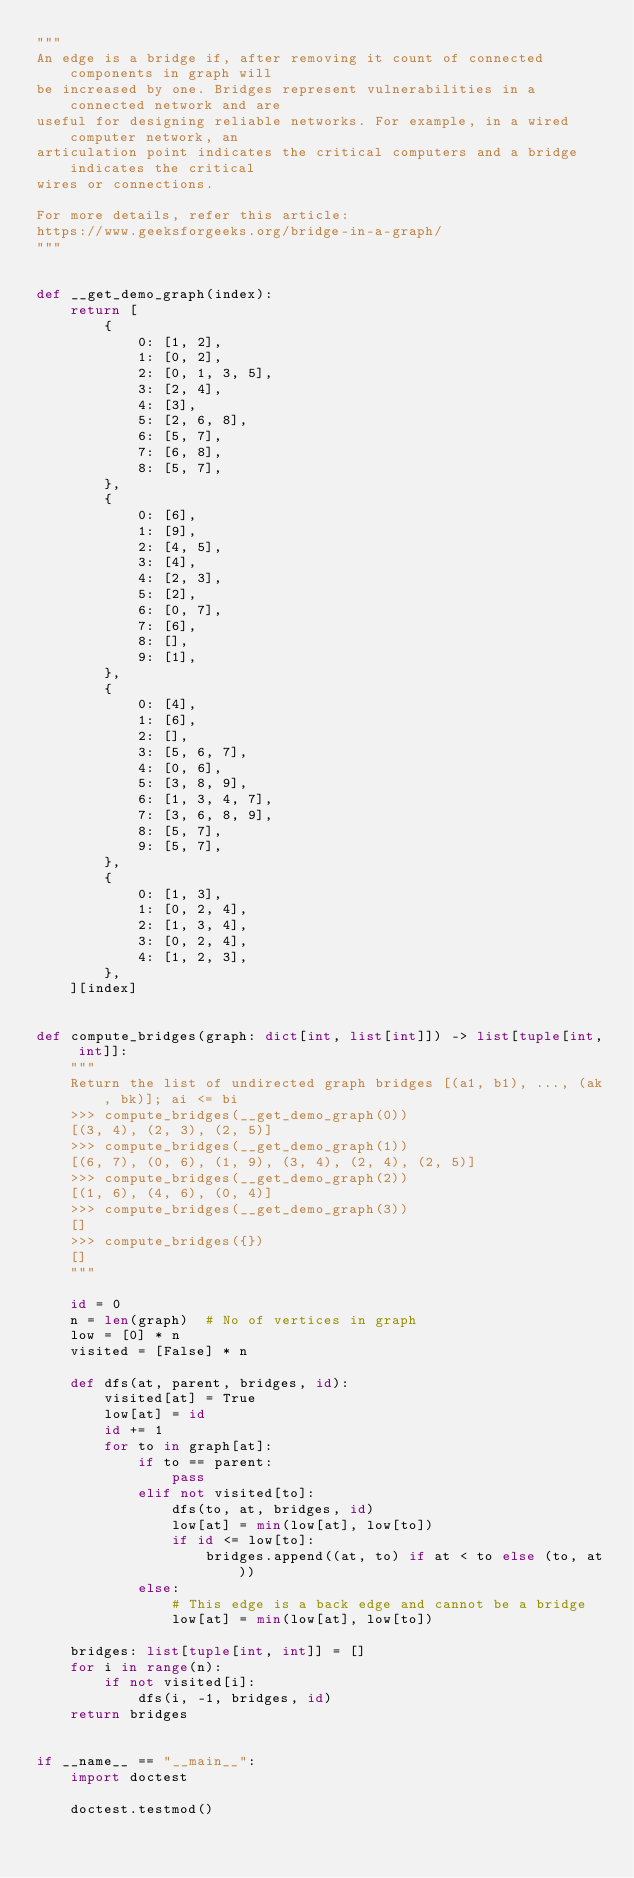<code> <loc_0><loc_0><loc_500><loc_500><_Python_>"""
An edge is a bridge if, after removing it count of connected components in graph will
be increased by one. Bridges represent vulnerabilities in a connected network and are
useful for designing reliable networks. For example, in a wired computer network, an
articulation point indicates the critical computers and a bridge indicates the critical
wires or connections.

For more details, refer this article:
https://www.geeksforgeeks.org/bridge-in-a-graph/
"""


def __get_demo_graph(index):
    return [
        {
            0: [1, 2],
            1: [0, 2],
            2: [0, 1, 3, 5],
            3: [2, 4],
            4: [3],
            5: [2, 6, 8],
            6: [5, 7],
            7: [6, 8],
            8: [5, 7],
        },
        {
            0: [6],
            1: [9],
            2: [4, 5],
            3: [4],
            4: [2, 3],
            5: [2],
            6: [0, 7],
            7: [6],
            8: [],
            9: [1],
        },
        {
            0: [4],
            1: [6],
            2: [],
            3: [5, 6, 7],
            4: [0, 6],
            5: [3, 8, 9],
            6: [1, 3, 4, 7],
            7: [3, 6, 8, 9],
            8: [5, 7],
            9: [5, 7],
        },
        {
            0: [1, 3],
            1: [0, 2, 4],
            2: [1, 3, 4],
            3: [0, 2, 4],
            4: [1, 2, 3],
        },
    ][index]


def compute_bridges(graph: dict[int, list[int]]) -> list[tuple[int, int]]:
    """
    Return the list of undirected graph bridges [(a1, b1), ..., (ak, bk)]; ai <= bi
    >>> compute_bridges(__get_demo_graph(0))
    [(3, 4), (2, 3), (2, 5)]
    >>> compute_bridges(__get_demo_graph(1))
    [(6, 7), (0, 6), (1, 9), (3, 4), (2, 4), (2, 5)]
    >>> compute_bridges(__get_demo_graph(2))
    [(1, 6), (4, 6), (0, 4)]
    >>> compute_bridges(__get_demo_graph(3))
    []
    >>> compute_bridges({})
    []
    """

    id = 0
    n = len(graph)  # No of vertices in graph
    low = [0] * n
    visited = [False] * n

    def dfs(at, parent, bridges, id):
        visited[at] = True
        low[at] = id
        id += 1
        for to in graph[at]:
            if to == parent:
                pass
            elif not visited[to]:
                dfs(to, at, bridges, id)
                low[at] = min(low[at], low[to])
                if id <= low[to]:
                    bridges.append((at, to) if at < to else (to, at))
            else:
                # This edge is a back edge and cannot be a bridge
                low[at] = min(low[at], low[to])

    bridges: list[tuple[int, int]] = []
    for i in range(n):
        if not visited[i]:
            dfs(i, -1, bridges, id)
    return bridges


if __name__ == "__main__":
    import doctest

    doctest.testmod()
</code> 